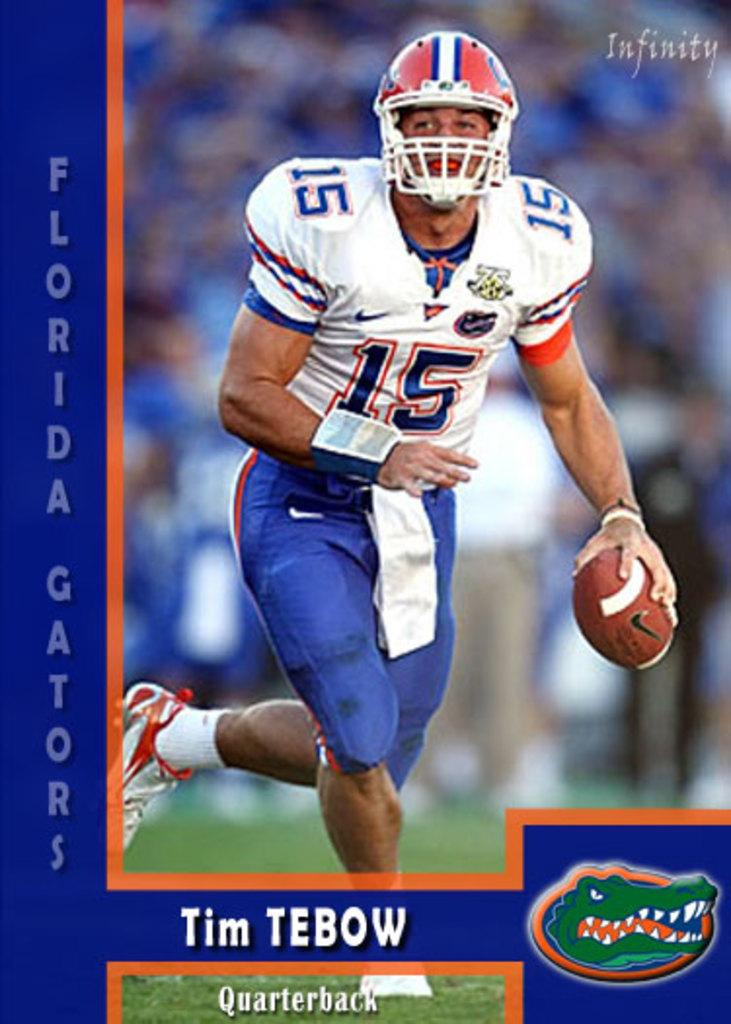What is the main subject of the image? The main subject of the image is a photograph. What is depicted in the photograph? The photograph features a rugby player. What is the rugby player doing in the image? The rugby player is running and holding a ball. What type of clothing is the rugby player wearing? The rugby player is wearing sportswear and a helmet. What text is present in the image? The text "Florida caterers" is present in the image. Can you hear the whistle in the image? There is no whistle present in the image; it is a photograph of a rugby player running and holding a ball. Are there any dogs visible in the image? There are no dogs present in the image; it features a rugby player and the text "Florida caterers." 